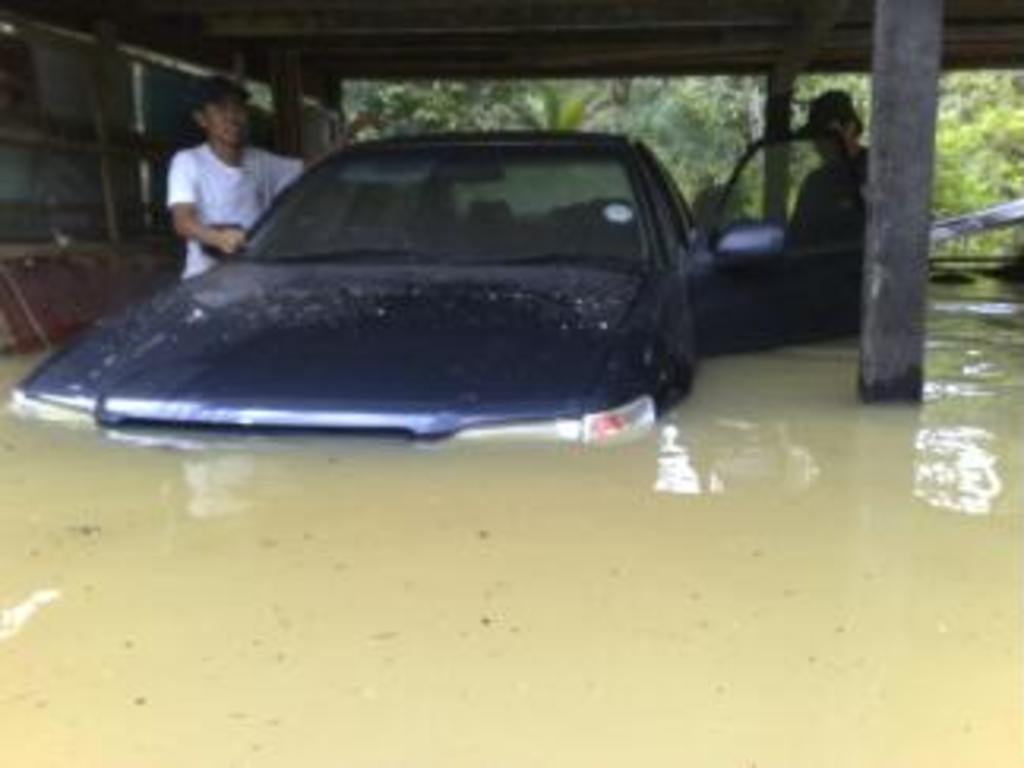Please provide a concise description of this image. In this image, we can see the car in the water, there are some people standing, we can see some pillars and there is a shed. 